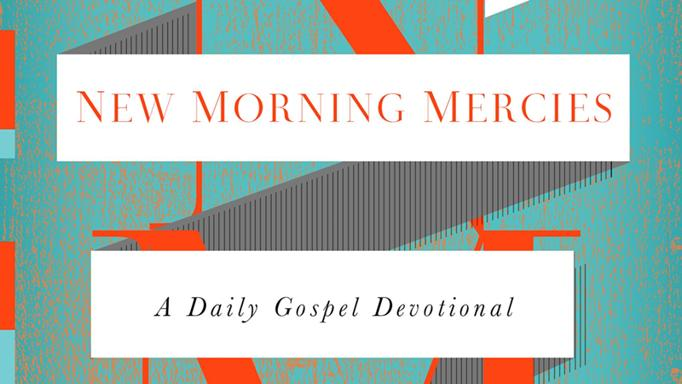What is the title of the devotional in the image? The title of the devotional displayed in the image is 'New Morning Mercies: A Daily Gospel Devotional.' This book provides daily devotional readings, incorporating vibrant typographic design to engage and inspire readers. 